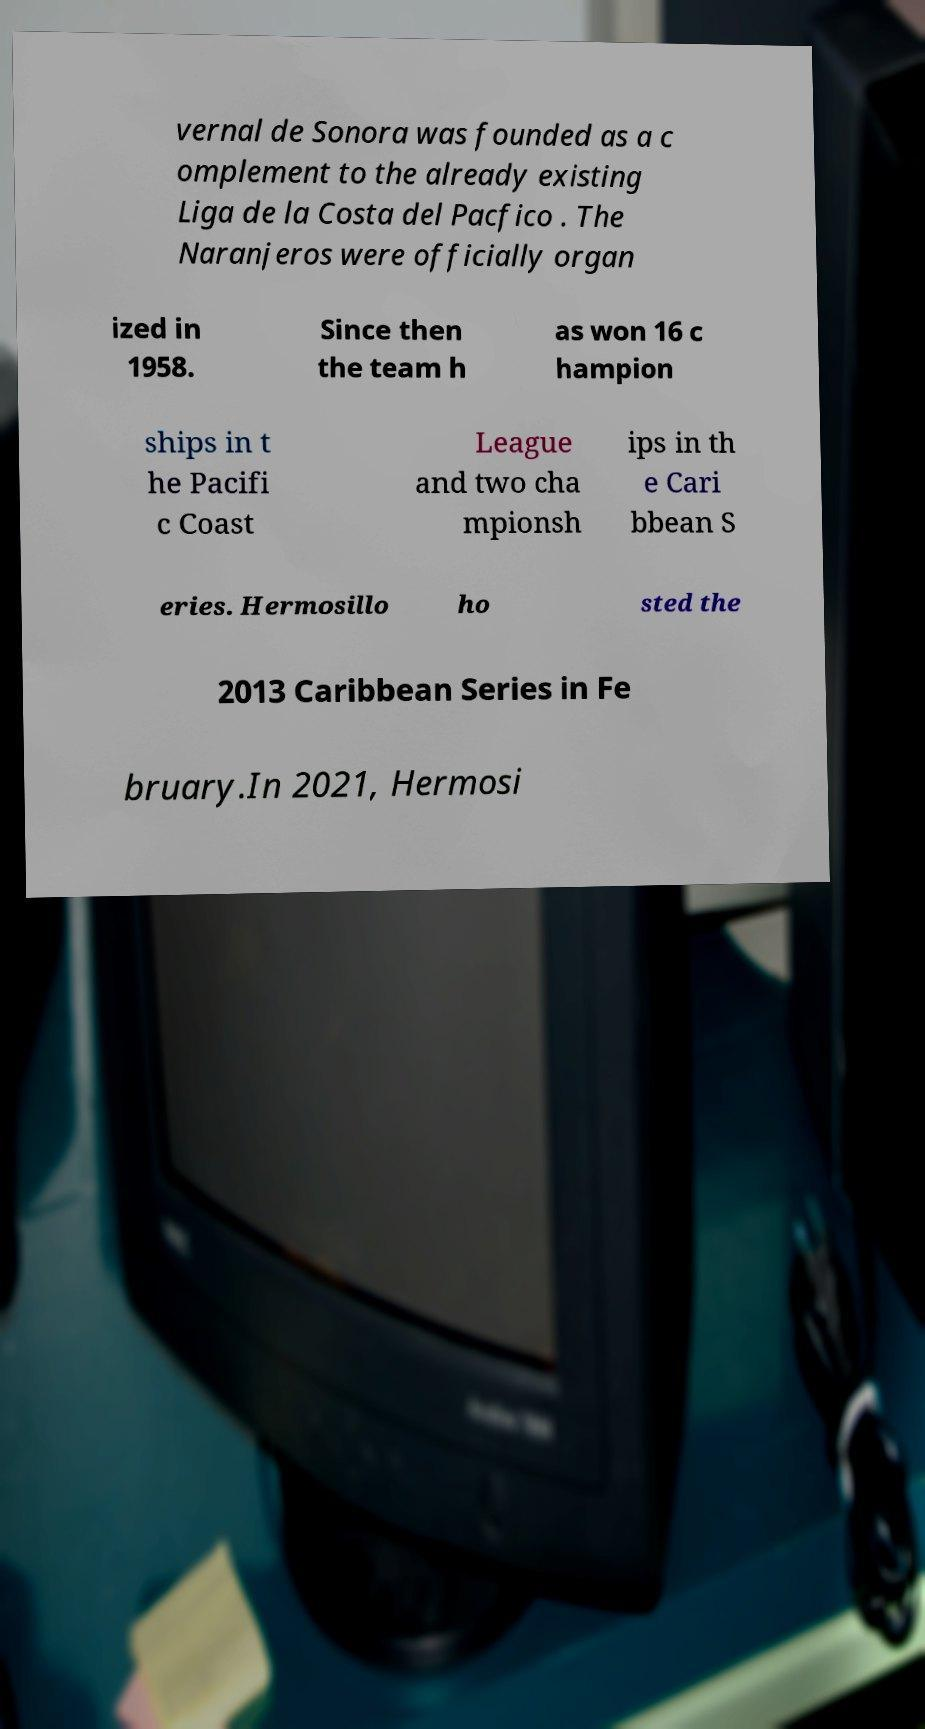Can you accurately transcribe the text from the provided image for me? vernal de Sonora was founded as a c omplement to the already existing Liga de la Costa del Pacfico . The Naranjeros were officially organ ized in 1958. Since then the team h as won 16 c hampion ships in t he Pacifi c Coast League and two cha mpionsh ips in th e Cari bbean S eries. Hermosillo ho sted the 2013 Caribbean Series in Fe bruary.In 2021, Hermosi 